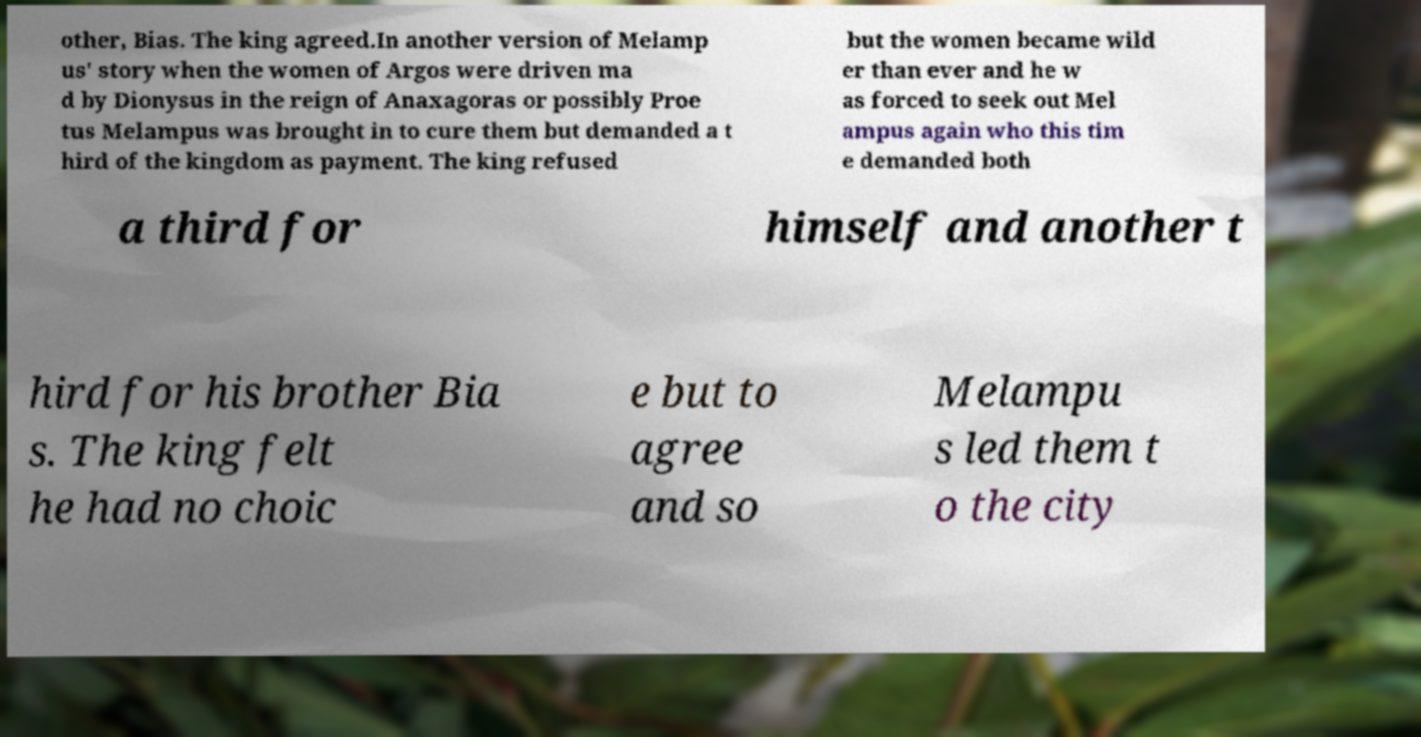Please read and relay the text visible in this image. What does it say? other, Bias. The king agreed.In another version of Melamp us' story when the women of Argos were driven ma d by Dionysus in the reign of Anaxagoras or possibly Proe tus Melampus was brought in to cure them but demanded a t hird of the kingdom as payment. The king refused but the women became wild er than ever and he w as forced to seek out Mel ampus again who this tim e demanded both a third for himself and another t hird for his brother Bia s. The king felt he had no choic e but to agree and so Melampu s led them t o the city 